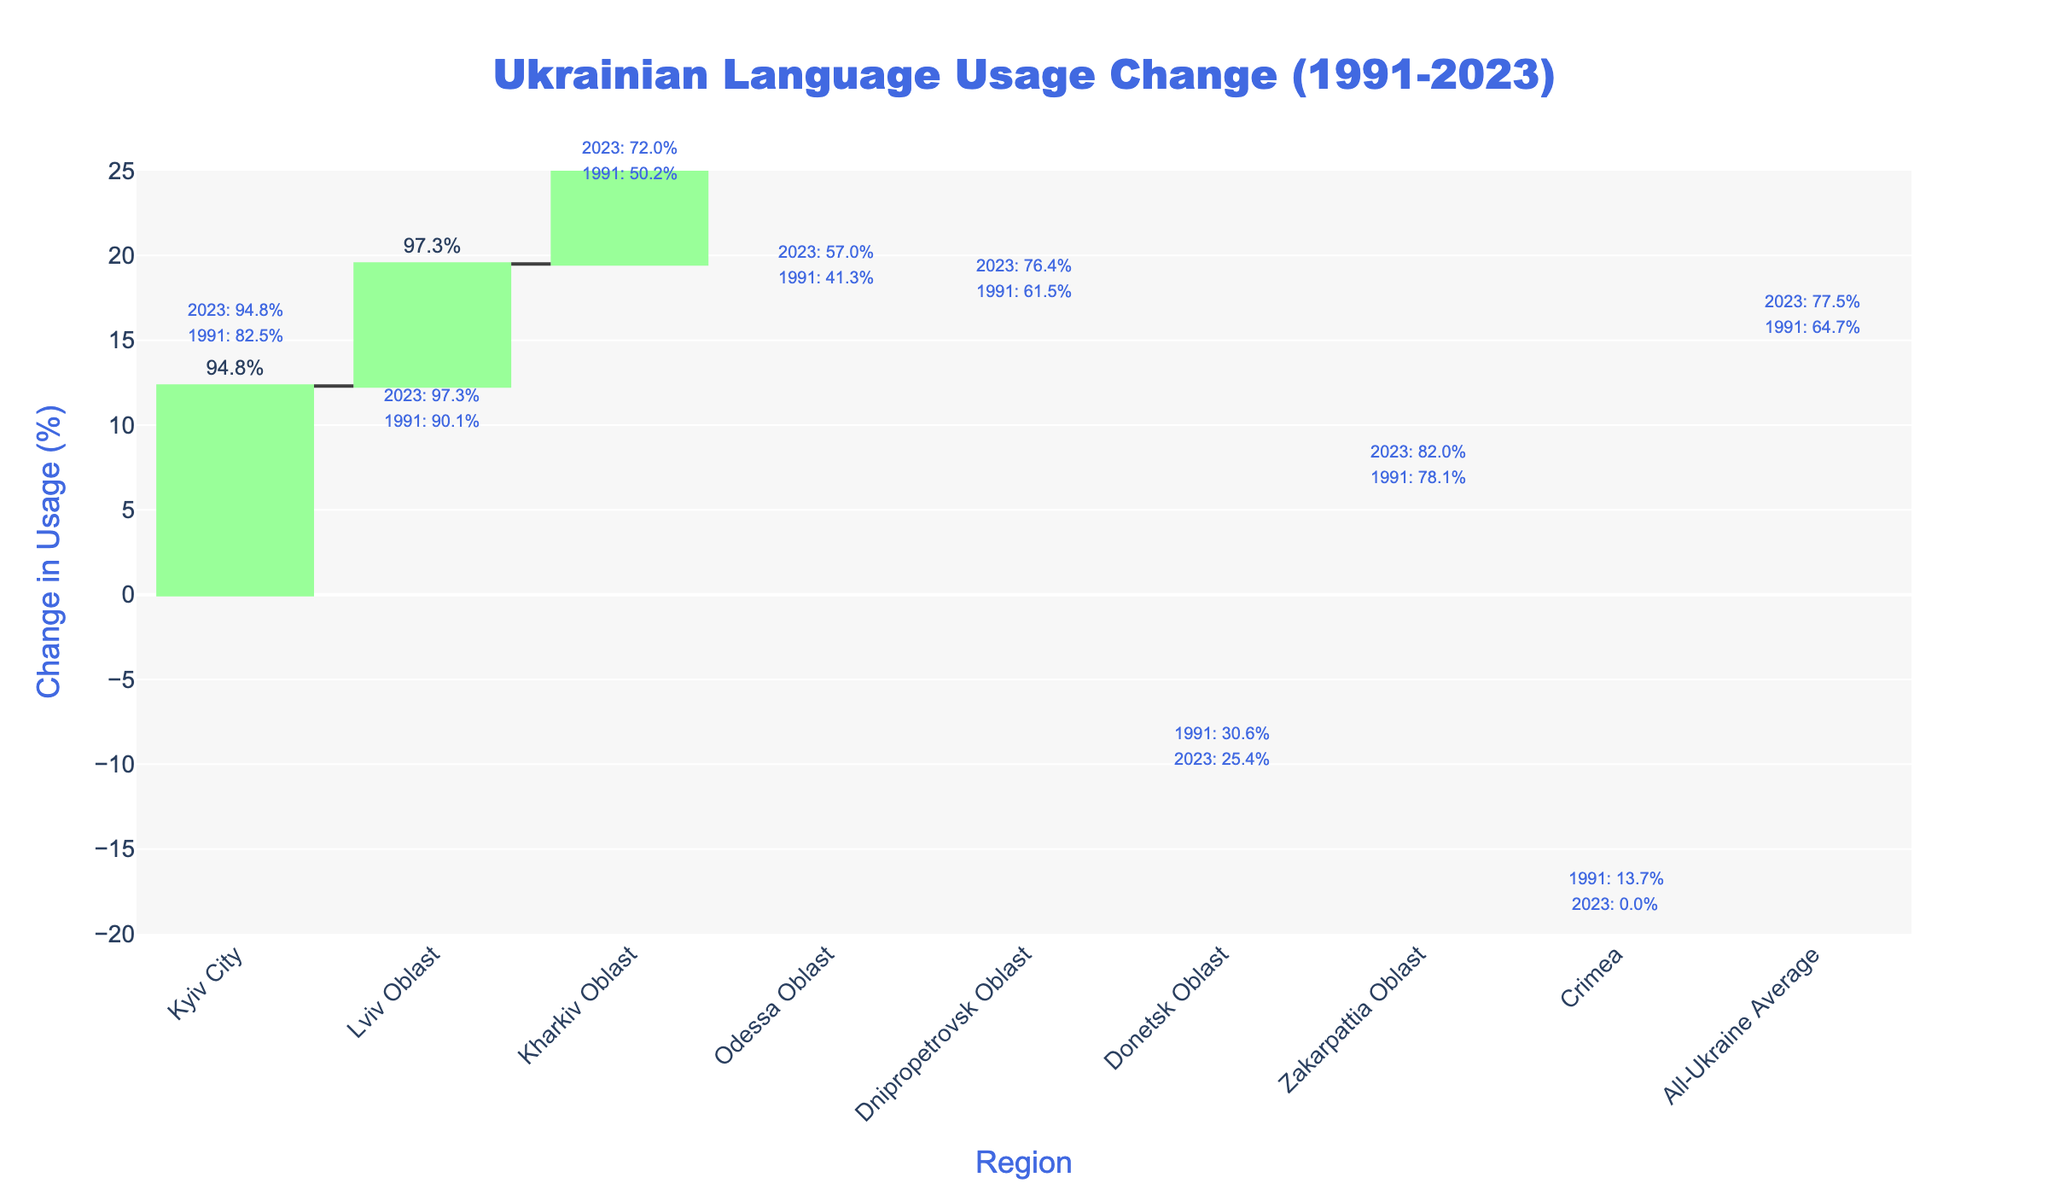What is the title of the chart? The title is displayed at the top of the chart, centered and in large blue font. It reads "Ukrainian Language Usage Change (1991-2023)."
Answer: Ukrainian Language Usage Change (1991-2023) Which region saw the largest increase in Ukrainian language usage? By looking at the height of the green bars on the chart, the largest increase is indicated in Kharkiv Oblast, with an increase of +21.8%.
Answer: Kharkiv Oblast What is the Ukrainian language usage percentage in Kyiv City for the year 2023? The 2023 value for Kyiv City is displayed outside the bar for that region. The value is 94.8%.
Answer: 94.8% Which regions experienced a decrease in the percentage of Ukrainian language usage? The regions with red bars indicate a decrease. The regions are Donetsk Oblast and Crimea, with changes of -5.2% and -13.7%, respectively.
Answer: Donetsk Oblast, Crimea How did the Ukrainian language usage in the Lviv Oblast change from 1991 to 2023? The waterfall chart shows the initial value from 1991 and the change, leading to the 2023 value. Lviv Oblast started at 90.1%, increased by 7.2%, resulting in 97.3% in 2023.
Answer: Increased by 7.2% What is the net change across all regions shown in the chart? To determine the net change, look at the total bar which sums the individual changes for all the regions. The net change is +12.8% as indicated for the All-Ukraine Average.
Answer: +12.8% Which region had no Ukrainian language usage in the present year (2023)? By inspecting the percentages for the year 2023, Crimea has 0.0%, indicating no usage in 2023.
Answer: Crimea What is the relative difference in Ukrainian language usage between 1991 and 2023 for Kharkiv Oblast? Kharkiv Oblast had 50.2% usage in 1991 and 72.0% in 2023. The relative difference is 72.0% - 50.2% = 21.8%.
Answer: 21.8% Which regions have Ukrainian language usage above the 2023 All-Ukraine Average? The All-Ukraine Average for 2023 is 77.5%. The regions above this average are Kyiv City (94.8%), Lviv Oblast (97.3%), and Zakarpattia Oblast (82.0%).
Answer: Kyiv City, Lviv Oblast, Zakarpattia Oblast 